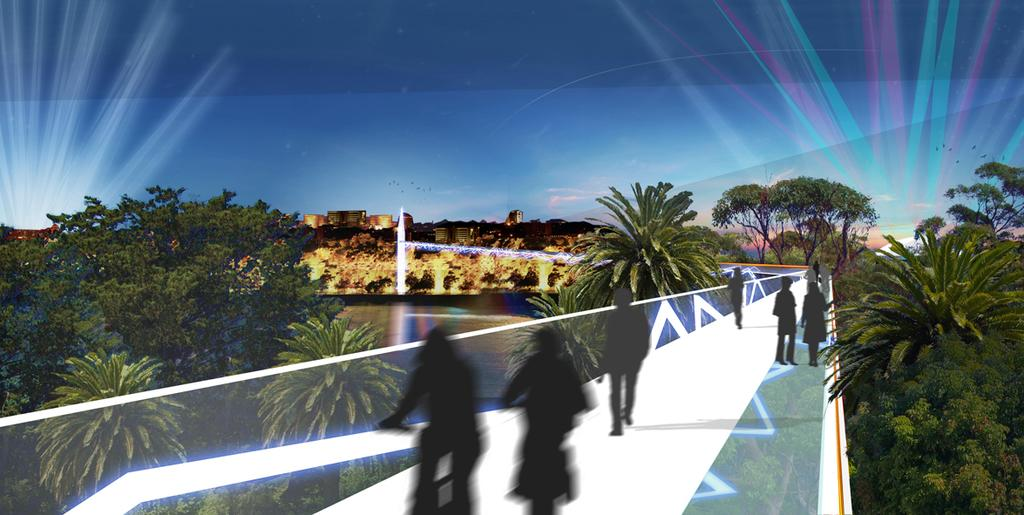What type of character is present in the image? There is an animated person in the image. What type of natural environment is visible in the image? There are trees in the image. What type of man-made structures are visible in the image? There are buildings in the image. What is visible in the sky in the image? The sky is visible in the image. How many arms does the animated person have in the image? The number of arms the animated person has cannot be determined from the image. What type of experience does the animated person have in the image? There is no indication of any specific experience the animated person is having in the image. How many girls are present in the image? There is no mention of any girls in the image. 